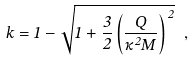<formula> <loc_0><loc_0><loc_500><loc_500>k = 1 - \sqrt { 1 + \frac { 3 } { 2 } \left ( \frac { Q } { \kappa ^ { 2 } M } \right ) ^ { \, 2 } } \ ,</formula> 